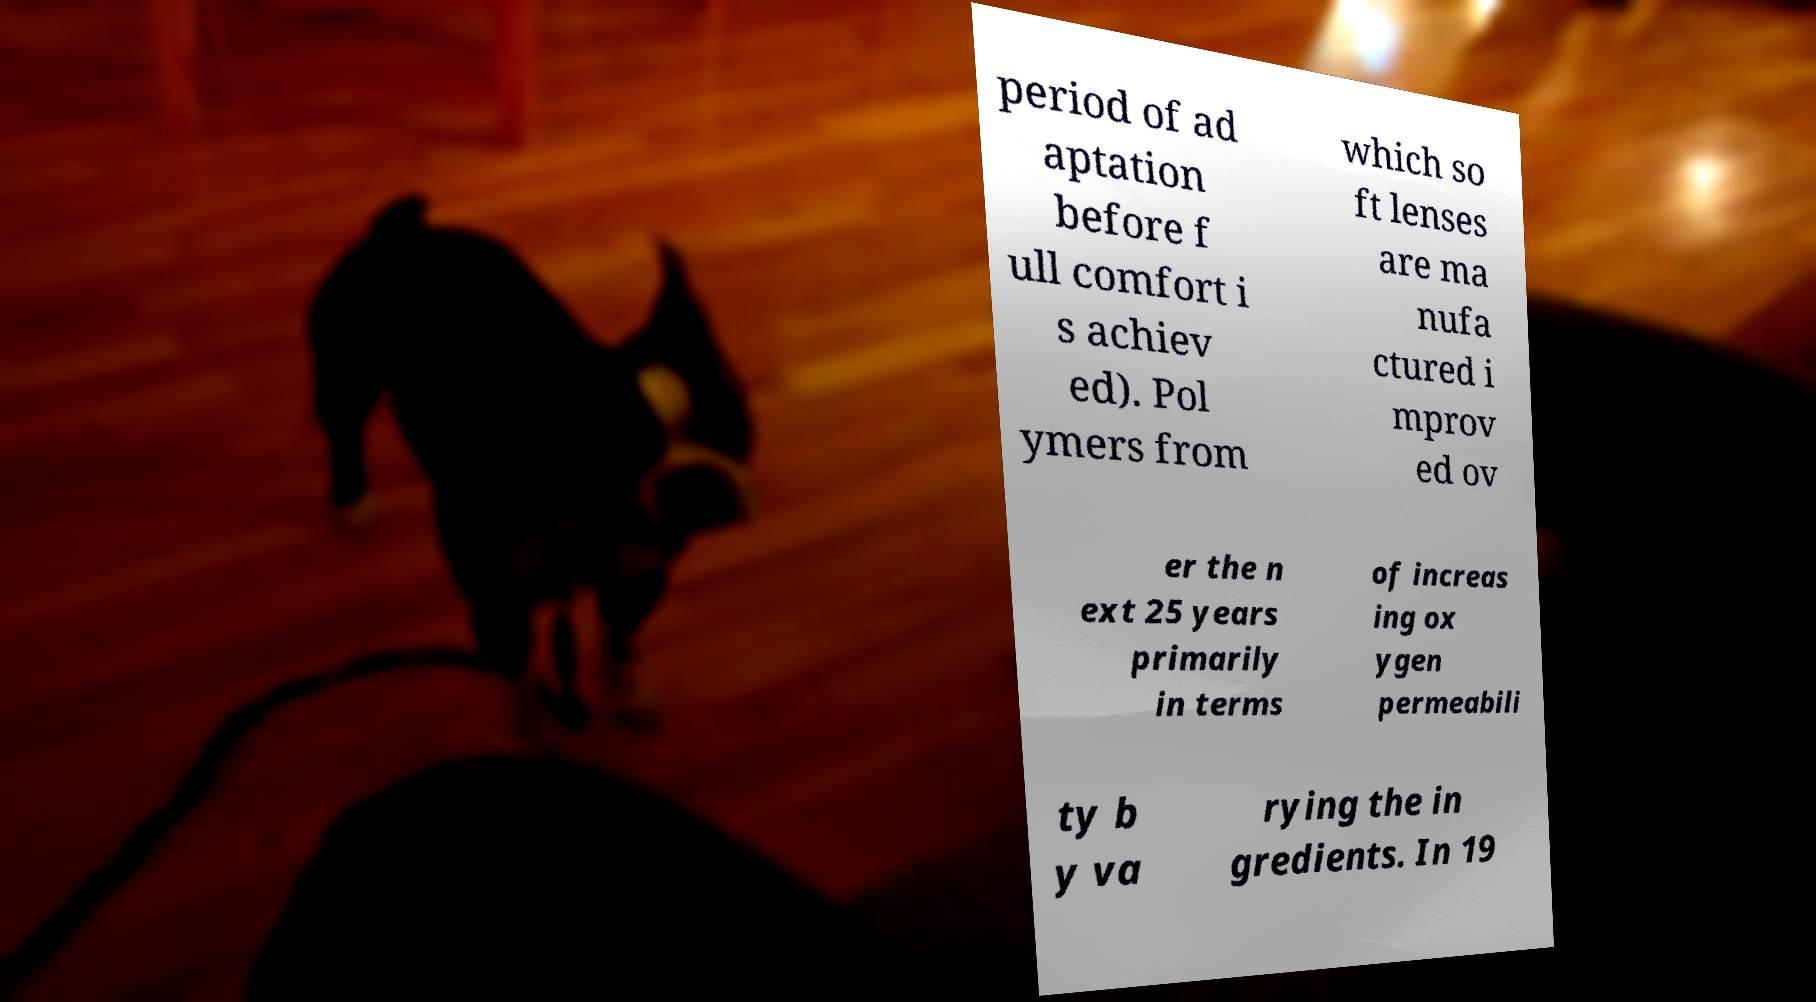Can you accurately transcribe the text from the provided image for me? period of ad aptation before f ull comfort i s achiev ed). Pol ymers from which so ft lenses are ma nufa ctured i mprov ed ov er the n ext 25 years primarily in terms of increas ing ox ygen permeabili ty b y va rying the in gredients. In 19 